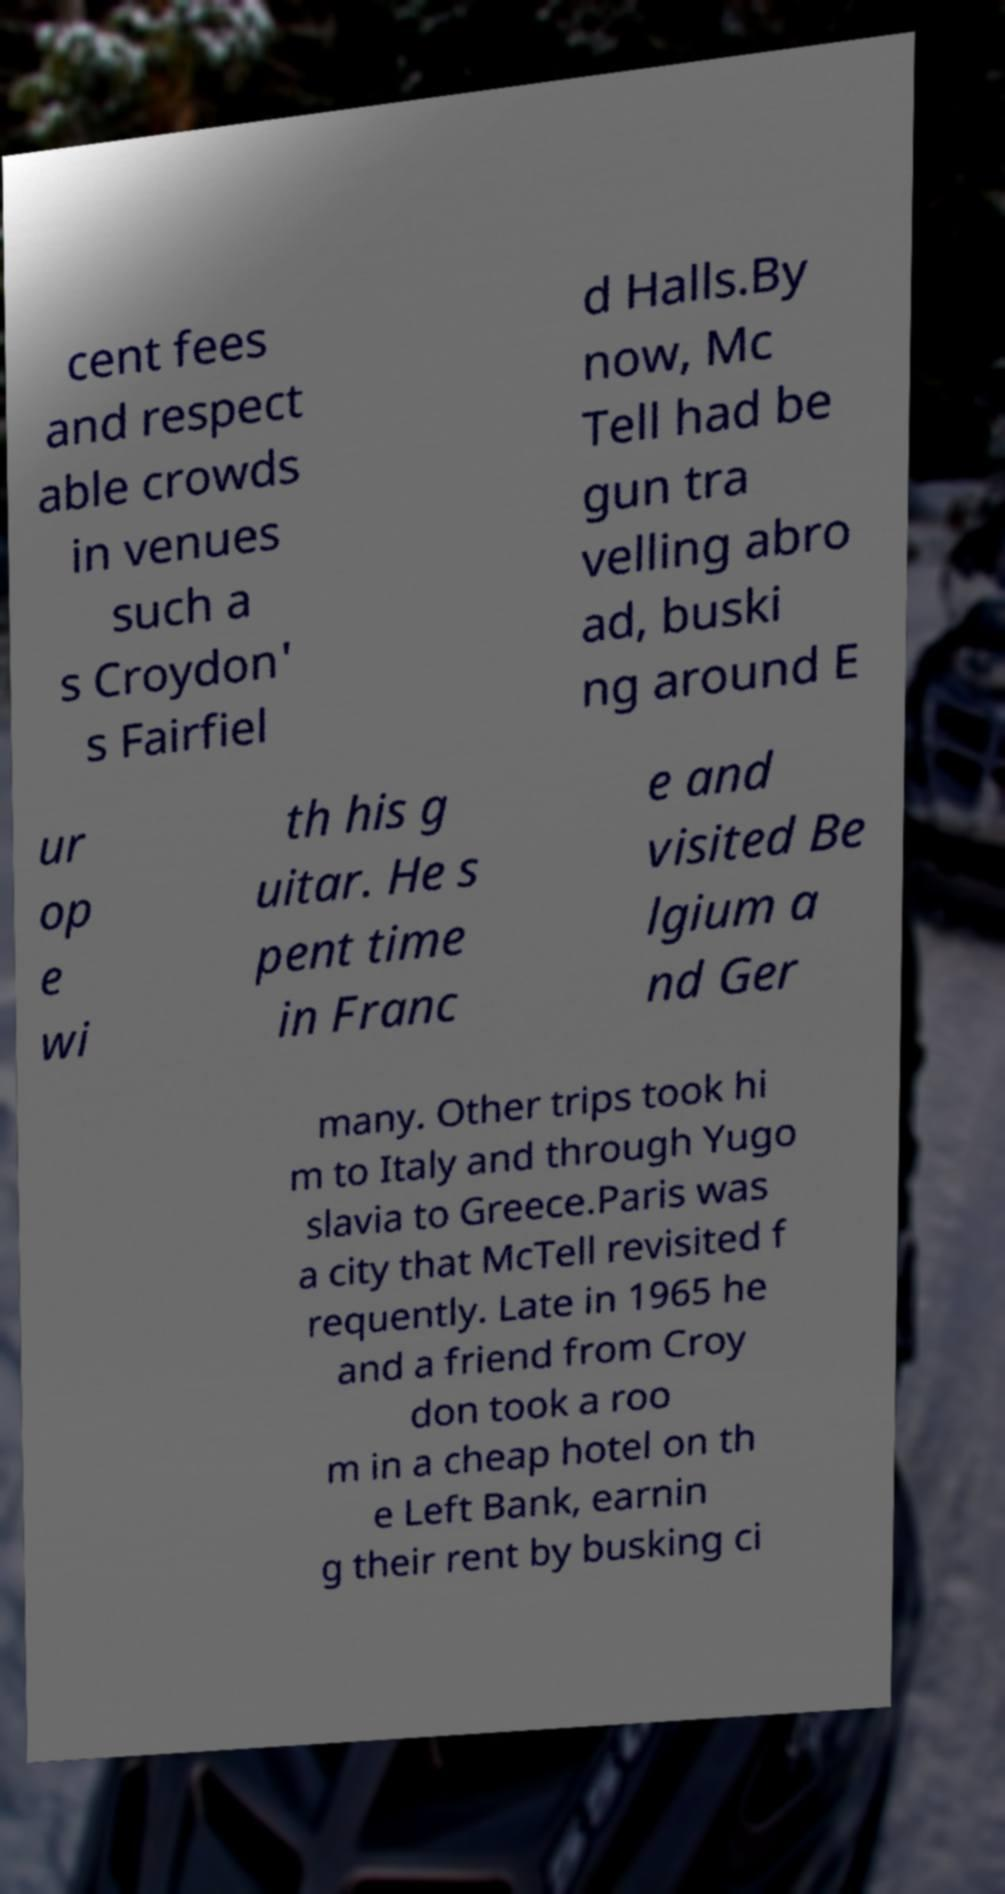For documentation purposes, I need the text within this image transcribed. Could you provide that? cent fees and respect able crowds in venues such a s Croydon' s Fairfiel d Halls.By now, Mc Tell had be gun tra velling abro ad, buski ng around E ur op e wi th his g uitar. He s pent time in Franc e and visited Be lgium a nd Ger many. Other trips took hi m to Italy and through Yugo slavia to Greece.Paris was a city that McTell revisited f requently. Late in 1965 he and a friend from Croy don took a roo m in a cheap hotel on th e Left Bank, earnin g their rent by busking ci 